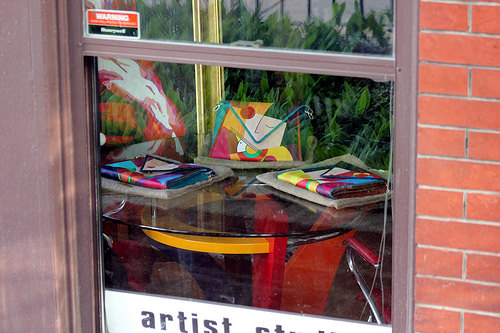<image>
Is the table behind the window? Yes. From this viewpoint, the table is positioned behind the window, with the window partially or fully occluding the table. 